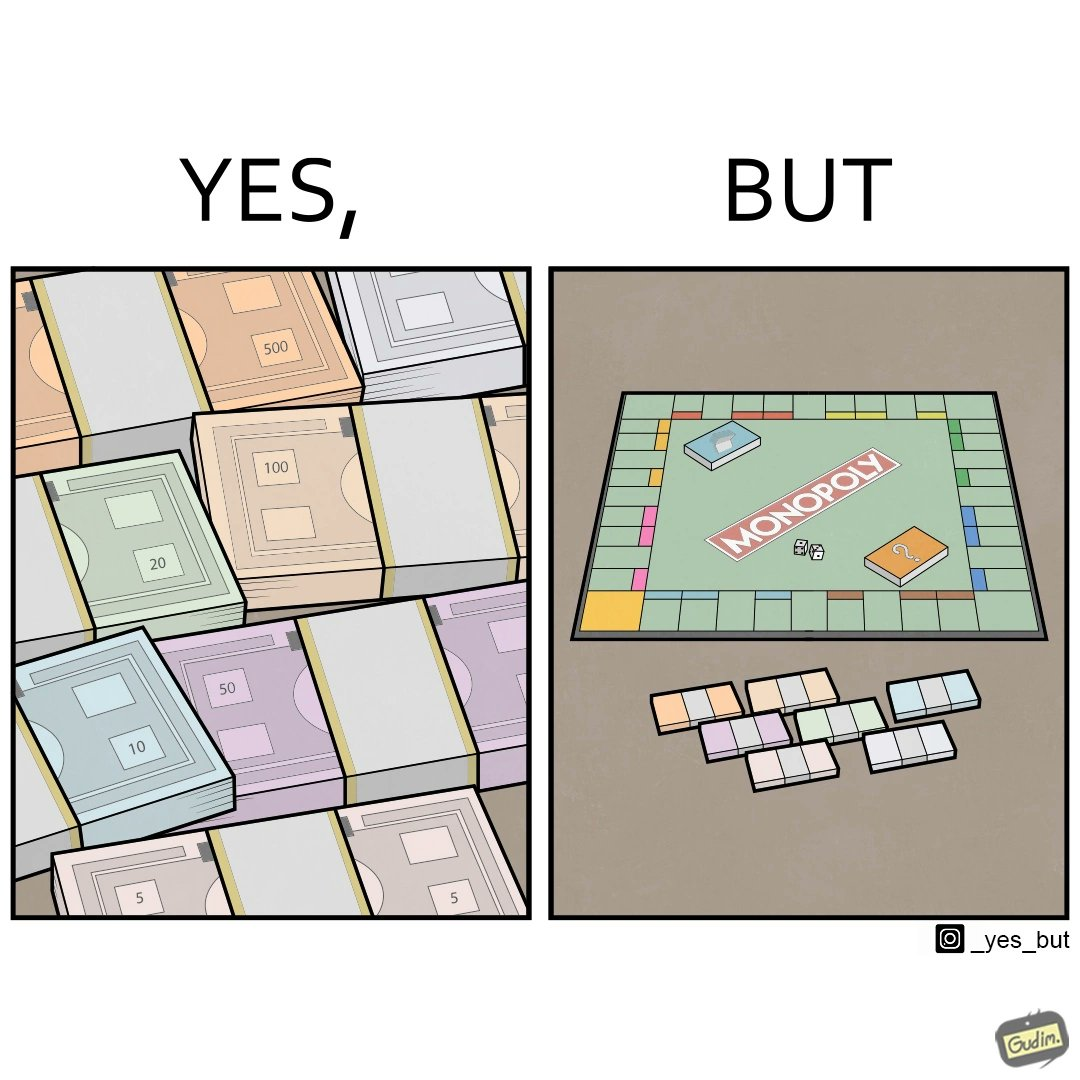Provide a description of this image. The image is ironic, because there are many different color currency notes' bundles but they are just as a currency in the game of monopoly and they have no real value 